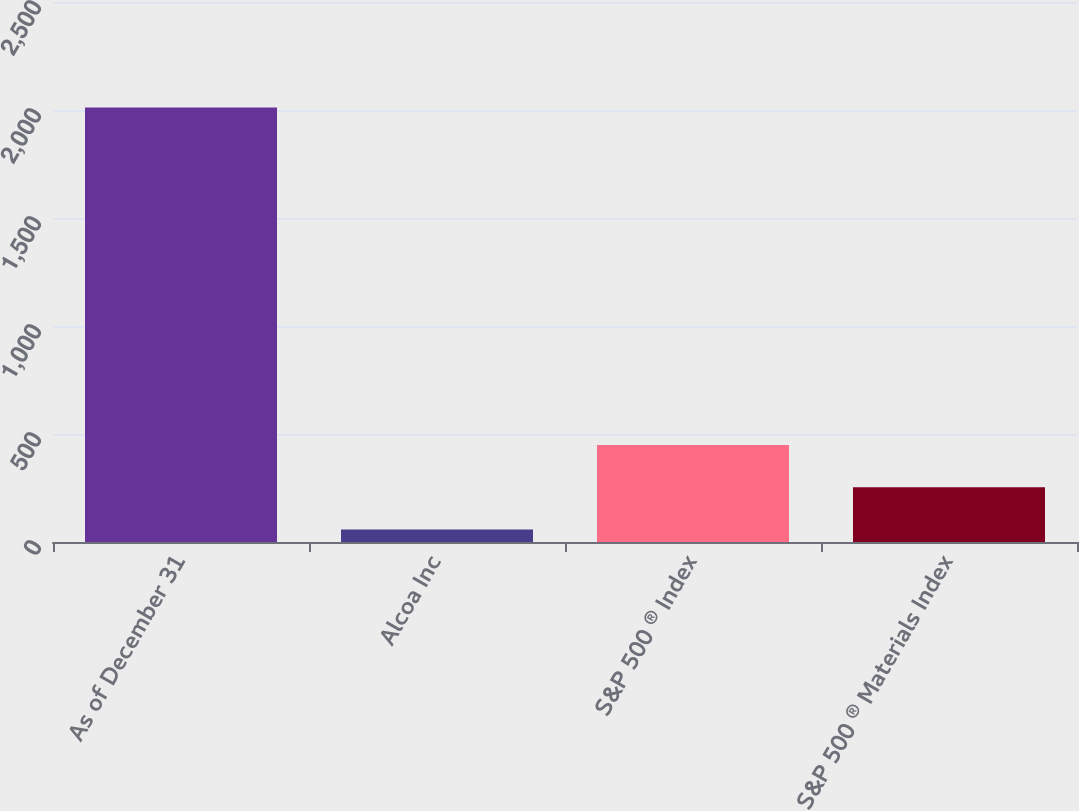Convert chart. <chart><loc_0><loc_0><loc_500><loc_500><bar_chart><fcel>As of December 31<fcel>Alcoa Inc<fcel>S&P 500 ® Index<fcel>S&P 500 ® Materials Index<nl><fcel>2012<fcel>58<fcel>448.8<fcel>253.4<nl></chart> 